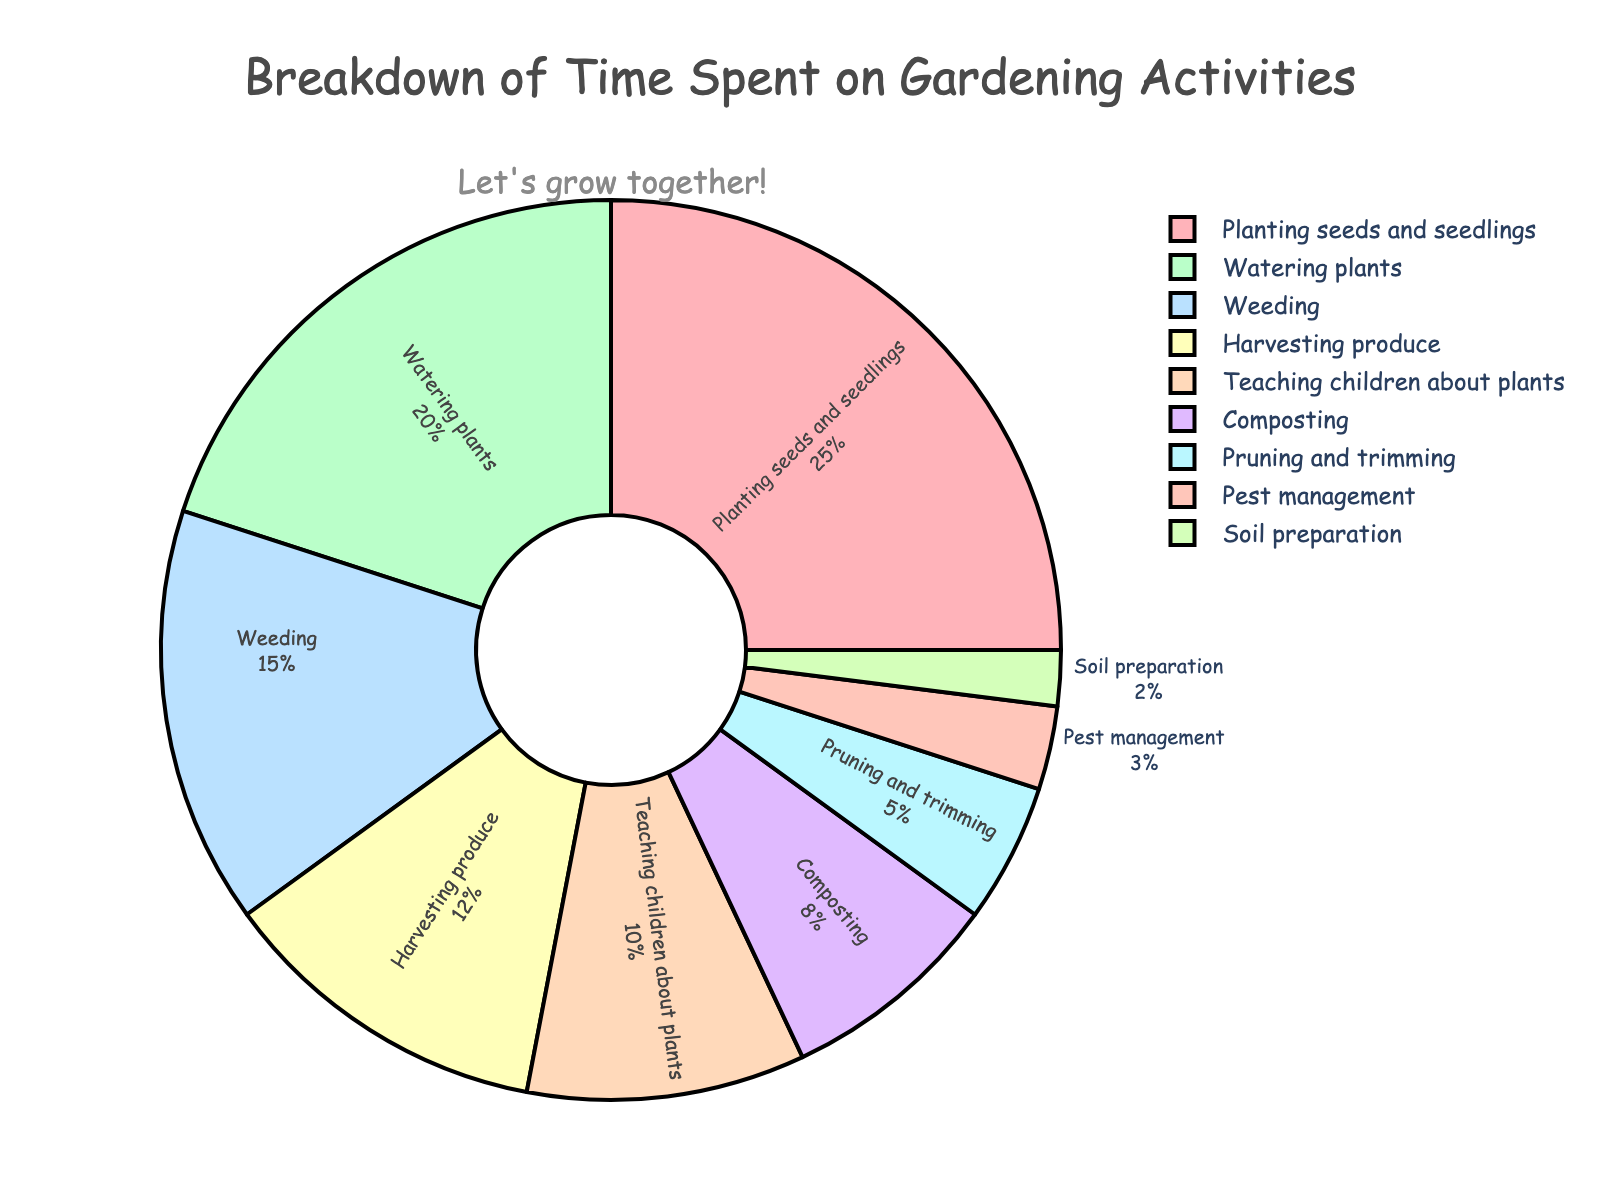Which gardening activity takes up the most time? Look at the segment with the largest percentage. "Planting seeds and seedlings" has the highest value at 25%.
Answer: Planting seeds and seedlings How much time is spent on "Harvesting produce" and "Weeding" combined? Add the percentages for "Harvesting produce" (12%) and "Weeding" (15%). 12% + 15% = 27%.
Answer: 27% Which activity takes less time: "Pruning and trimming" or "Composting"? Compare "Pruning and trimming" (5%) with "Composting" (8%). "Pruning and trimming" takes less time.
Answer: Pruning and trimming Is more time spent on "Teaching children about plants" or on "Soil preparation"? Compare "Teaching children about plants" (10%) with "Soil preparation" (2%). "Teaching children about plants" takes more time.
Answer: Teaching children about plants How much more time is spent on "Watering plants" compared to "Pest management"? Subtract the percentage of "Pest management" (3%) from "Watering plants" (20%). 20% - 3% = 17%.
Answer: 17% What fraction of time is spent on activities related to plant care (Planting seeds and seedlings, Watering plants, Weeding, Pruning and trimming, Pest management)? Add the percentages for relevant activities: Planting seeds and seedlings (25%), Watering plants (20%), Weeding (15%), Pruning and trimming (5%), Pest management (3%). Total: 25% + 20% + 15% + 5% + 3% = 68%.
Answer: 68% What is the combined percentage of time spent on "Soil preparation" and "Pruning and trimming"? Add the percentages for "Soil preparation" (2%) and "Pruning and trimming" (5%). 2% + 5% = 7%.
Answer: 7% Identify the color used for "Composting" in the pie chart. The color assigned to "Composting" is visually seen in the chart. It is the 6th color in the legend order, which is light purple.
Answer: Light purple Which activities collectively take up exactly half of the total time spent? Identify which activities' percentages sum up to 50%. "Planting seeds and seedlings" (25%), "Watering plants" (20%), and "Soil preparation" (2%) collectively add up to 47%, while "Weeding" (15%) and "Harvesting produce" (12%) add up to 27%. Therefore, "Watering plants" and "Planting seeds and seedlings" add up to 45%, while "Watering plants" and "Weeding" add up to 35%. Neither combination exactly sums to 50%.
Answer: None 